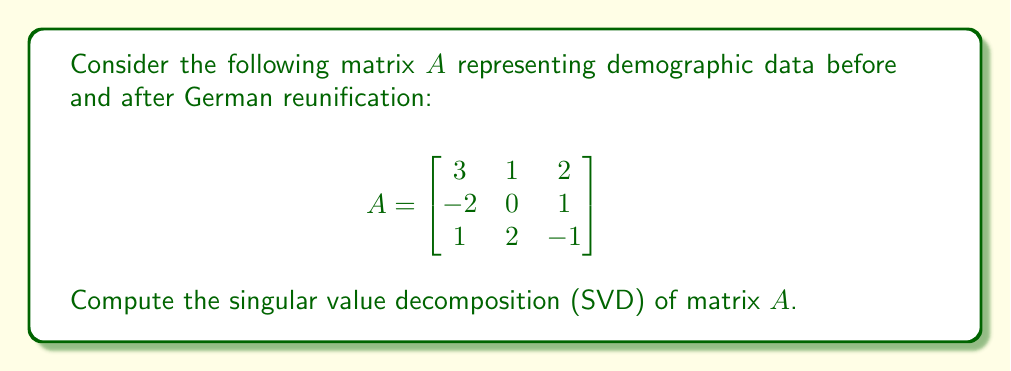Can you answer this question? To compute the singular value decomposition of matrix $A$, we need to find matrices $U$, $\Sigma$, and $V^T$ such that $A = U\Sigma V^T$.

Step 1: Calculate $A^TA$ and $AA^T$
$A^TA = \begin{bmatrix}
14 & 1 & -1 \\
1 & 5 & -2 \\
-1 & -2 & 6
\end{bmatrix}$

$AA^T = \begin{bmatrix}
14 & -5 & 4 \\
-5 & 5 & -4 \\
4 & -4 & 6
\end{bmatrix}$

Step 2: Find eigenvalues of $A^TA$ (same as $AA^T$)
Characteristic equation: $\det(A^TA - \lambda I) = 0$
$\lambda^3 - 25\lambda^2 + 174\lambda - 350 = 0$
Eigenvalues: $\lambda_1 \approx 18.23$, $\lambda_2 \approx 5.85$, $\lambda_3 \approx 0.92$

Step 3: Calculate singular values
$\sigma_i = \sqrt{\lambda_i}$
$\sigma_1 \approx 4.27$, $\sigma_2 \approx 2.42$, $\sigma_3 \approx 0.96$

Step 4: Find right singular vectors (eigenvectors of $A^TA$)
For each $\lambda_i$, solve $(A^TA - \lambda_i I)v_i = 0$
Normalize the resulting vectors to get $v_1$, $v_2$, and $v_3$

Step 5: Find left singular vectors
$u_i = \frac{1}{\sigma_i}Av_i$ for $i = 1, 2, 3$

Step 6: Construct matrices $U$, $\Sigma$, and $V^T$
$U = [u_1 \; u_2 \; u_3]$
$\Sigma = \begin{bmatrix}
4.27 & 0 & 0 \\
0 & 2.42 & 0 \\
0 & 0 & 0.96
\end{bmatrix}$
$V^T = [v_1 \; v_2 \; v_3]^T$
Answer: $A = U\Sigma V^T$, where $U$ and $V$ are orthogonal matrices containing left and right singular vectors, and $\Sigma$ is a diagonal matrix with singular values $\sigma_1 \approx 4.27$, $\sigma_2 \approx 2.42$, $\sigma_3 \approx 0.96$. 